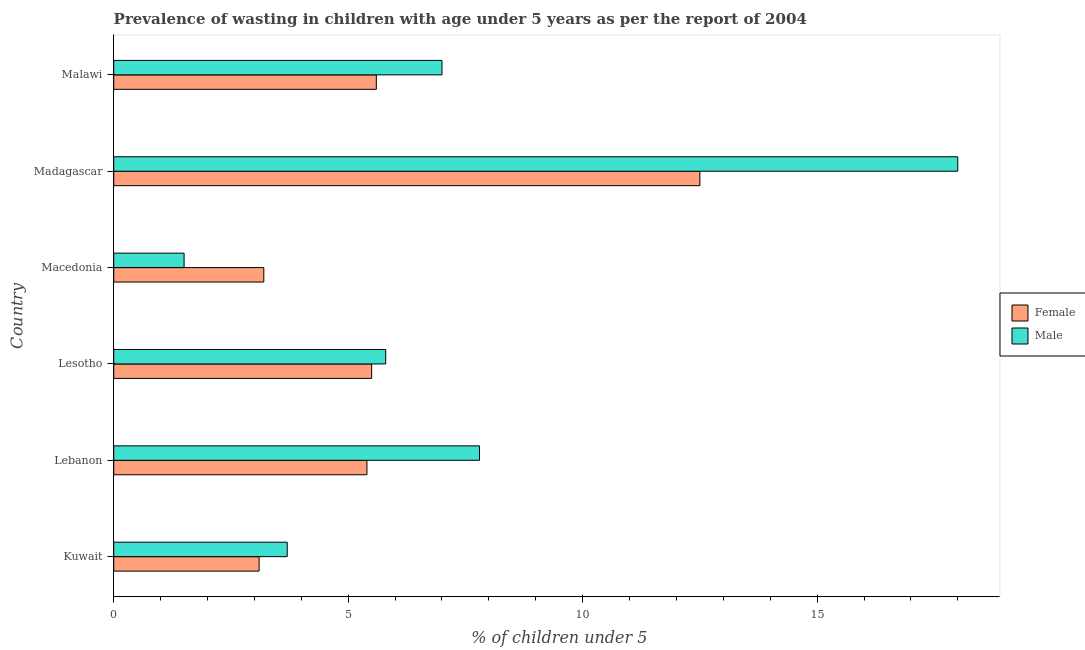How many different coloured bars are there?
Keep it short and to the point. 2. How many groups of bars are there?
Give a very brief answer. 6. Are the number of bars per tick equal to the number of legend labels?
Ensure brevity in your answer.  Yes. What is the label of the 3rd group of bars from the top?
Provide a succinct answer. Macedonia. In how many cases, is the number of bars for a given country not equal to the number of legend labels?
Give a very brief answer. 0. Across all countries, what is the maximum percentage of undernourished female children?
Offer a very short reply. 12.5. Across all countries, what is the minimum percentage of undernourished female children?
Provide a succinct answer. 3.1. In which country was the percentage of undernourished female children maximum?
Offer a terse response. Madagascar. In which country was the percentage of undernourished male children minimum?
Keep it short and to the point. Macedonia. What is the total percentage of undernourished female children in the graph?
Provide a short and direct response. 35.3. What is the difference between the percentage of undernourished male children in Lebanon and the percentage of undernourished female children in Macedonia?
Keep it short and to the point. 4.6. What is the average percentage of undernourished female children per country?
Your answer should be compact. 5.88. What is the difference between the percentage of undernourished male children and percentage of undernourished female children in Lebanon?
Offer a terse response. 2.4. What is the ratio of the percentage of undernourished male children in Kuwait to that in Lesotho?
Your answer should be very brief. 0.64. Is the difference between the percentage of undernourished male children in Lebanon and Madagascar greater than the difference between the percentage of undernourished female children in Lebanon and Madagascar?
Your answer should be compact. No. What is the difference between the highest and the second highest percentage of undernourished female children?
Your answer should be compact. 6.9. What is the difference between the highest and the lowest percentage of undernourished female children?
Offer a terse response. 9.4. In how many countries, is the percentage of undernourished female children greater than the average percentage of undernourished female children taken over all countries?
Provide a succinct answer. 1. Is the sum of the percentage of undernourished female children in Lebanon and Madagascar greater than the maximum percentage of undernourished male children across all countries?
Make the answer very short. No. What does the 1st bar from the bottom in Madagascar represents?
Offer a terse response. Female. How many bars are there?
Offer a very short reply. 12. Are all the bars in the graph horizontal?
Offer a very short reply. Yes. How many countries are there in the graph?
Offer a terse response. 6. What is the difference between two consecutive major ticks on the X-axis?
Your response must be concise. 5. Does the graph contain any zero values?
Provide a short and direct response. No. Where does the legend appear in the graph?
Ensure brevity in your answer.  Center right. How many legend labels are there?
Make the answer very short. 2. What is the title of the graph?
Give a very brief answer. Prevalence of wasting in children with age under 5 years as per the report of 2004. Does "Forest" appear as one of the legend labels in the graph?
Your answer should be compact. No. What is the label or title of the X-axis?
Your answer should be compact.  % of children under 5. What is the label or title of the Y-axis?
Ensure brevity in your answer.  Country. What is the  % of children under 5 of Female in Kuwait?
Provide a succinct answer. 3.1. What is the  % of children under 5 of Male in Kuwait?
Your response must be concise. 3.7. What is the  % of children under 5 in Female in Lebanon?
Your answer should be very brief. 5.4. What is the  % of children under 5 of Male in Lebanon?
Make the answer very short. 7.8. What is the  % of children under 5 of Male in Lesotho?
Keep it short and to the point. 5.8. What is the  % of children under 5 of Female in Macedonia?
Provide a succinct answer. 3.2. What is the  % of children under 5 of Male in Madagascar?
Offer a very short reply. 18. What is the  % of children under 5 in Female in Malawi?
Provide a succinct answer. 5.6. What is the  % of children under 5 in Male in Malawi?
Provide a succinct answer. 7. Across all countries, what is the maximum  % of children under 5 in Female?
Your answer should be compact. 12.5. Across all countries, what is the maximum  % of children under 5 in Male?
Make the answer very short. 18. Across all countries, what is the minimum  % of children under 5 in Female?
Offer a terse response. 3.1. Across all countries, what is the minimum  % of children under 5 in Male?
Keep it short and to the point. 1.5. What is the total  % of children under 5 in Female in the graph?
Ensure brevity in your answer.  35.3. What is the total  % of children under 5 of Male in the graph?
Offer a terse response. 43.8. What is the difference between the  % of children under 5 in Female in Kuwait and that in Lebanon?
Keep it short and to the point. -2.3. What is the difference between the  % of children under 5 in Female in Kuwait and that in Macedonia?
Provide a succinct answer. -0.1. What is the difference between the  % of children under 5 of Male in Kuwait and that in Macedonia?
Provide a short and direct response. 2.2. What is the difference between the  % of children under 5 of Male in Kuwait and that in Madagascar?
Provide a short and direct response. -14.3. What is the difference between the  % of children under 5 of Male in Kuwait and that in Malawi?
Keep it short and to the point. -3.3. What is the difference between the  % of children under 5 of Female in Lebanon and that in Lesotho?
Your answer should be very brief. -0.1. What is the difference between the  % of children under 5 of Female in Lebanon and that in Madagascar?
Keep it short and to the point. -7.1. What is the difference between the  % of children under 5 of Female in Lebanon and that in Malawi?
Your response must be concise. -0.2. What is the difference between the  % of children under 5 in Male in Lebanon and that in Malawi?
Your response must be concise. 0.8. What is the difference between the  % of children under 5 in Female in Lesotho and that in Madagascar?
Your response must be concise. -7. What is the difference between the  % of children under 5 in Male in Lesotho and that in Madagascar?
Ensure brevity in your answer.  -12.2. What is the difference between the  % of children under 5 of Female in Macedonia and that in Madagascar?
Your answer should be very brief. -9.3. What is the difference between the  % of children under 5 of Male in Macedonia and that in Madagascar?
Give a very brief answer. -16.5. What is the difference between the  % of children under 5 of Female in Macedonia and that in Malawi?
Provide a succinct answer. -2.4. What is the difference between the  % of children under 5 in Female in Kuwait and the  % of children under 5 in Male in Lesotho?
Your response must be concise. -2.7. What is the difference between the  % of children under 5 of Female in Kuwait and the  % of children under 5 of Male in Madagascar?
Offer a very short reply. -14.9. What is the difference between the  % of children under 5 in Female in Lebanon and the  % of children under 5 in Male in Lesotho?
Provide a succinct answer. -0.4. What is the difference between the  % of children under 5 of Female in Lebanon and the  % of children under 5 of Male in Macedonia?
Provide a succinct answer. 3.9. What is the difference between the  % of children under 5 in Female in Lebanon and the  % of children under 5 in Male in Malawi?
Your response must be concise. -1.6. What is the difference between the  % of children under 5 in Female in Macedonia and the  % of children under 5 in Male in Madagascar?
Give a very brief answer. -14.8. What is the average  % of children under 5 in Female per country?
Provide a short and direct response. 5.88. What is the difference between the  % of children under 5 of Female and  % of children under 5 of Male in Lesotho?
Your answer should be compact. -0.3. What is the difference between the  % of children under 5 in Female and  % of children under 5 in Male in Macedonia?
Keep it short and to the point. 1.7. What is the difference between the  % of children under 5 of Female and  % of children under 5 of Male in Madagascar?
Make the answer very short. -5.5. What is the ratio of the  % of children under 5 of Female in Kuwait to that in Lebanon?
Give a very brief answer. 0.57. What is the ratio of the  % of children under 5 in Male in Kuwait to that in Lebanon?
Make the answer very short. 0.47. What is the ratio of the  % of children under 5 in Female in Kuwait to that in Lesotho?
Ensure brevity in your answer.  0.56. What is the ratio of the  % of children under 5 in Male in Kuwait to that in Lesotho?
Keep it short and to the point. 0.64. What is the ratio of the  % of children under 5 in Female in Kuwait to that in Macedonia?
Give a very brief answer. 0.97. What is the ratio of the  % of children under 5 in Male in Kuwait to that in Macedonia?
Offer a very short reply. 2.47. What is the ratio of the  % of children under 5 in Female in Kuwait to that in Madagascar?
Ensure brevity in your answer.  0.25. What is the ratio of the  % of children under 5 in Male in Kuwait to that in Madagascar?
Keep it short and to the point. 0.21. What is the ratio of the  % of children under 5 of Female in Kuwait to that in Malawi?
Give a very brief answer. 0.55. What is the ratio of the  % of children under 5 in Male in Kuwait to that in Malawi?
Provide a succinct answer. 0.53. What is the ratio of the  % of children under 5 of Female in Lebanon to that in Lesotho?
Your response must be concise. 0.98. What is the ratio of the  % of children under 5 of Male in Lebanon to that in Lesotho?
Offer a terse response. 1.34. What is the ratio of the  % of children under 5 in Female in Lebanon to that in Macedonia?
Provide a short and direct response. 1.69. What is the ratio of the  % of children under 5 in Female in Lebanon to that in Madagascar?
Your response must be concise. 0.43. What is the ratio of the  % of children under 5 of Male in Lebanon to that in Madagascar?
Your answer should be compact. 0.43. What is the ratio of the  % of children under 5 in Male in Lebanon to that in Malawi?
Your response must be concise. 1.11. What is the ratio of the  % of children under 5 in Female in Lesotho to that in Macedonia?
Your answer should be compact. 1.72. What is the ratio of the  % of children under 5 of Male in Lesotho to that in Macedonia?
Provide a succinct answer. 3.87. What is the ratio of the  % of children under 5 of Female in Lesotho to that in Madagascar?
Offer a terse response. 0.44. What is the ratio of the  % of children under 5 of Male in Lesotho to that in Madagascar?
Your answer should be compact. 0.32. What is the ratio of the  % of children under 5 of Female in Lesotho to that in Malawi?
Provide a succinct answer. 0.98. What is the ratio of the  % of children under 5 of Male in Lesotho to that in Malawi?
Your answer should be compact. 0.83. What is the ratio of the  % of children under 5 of Female in Macedonia to that in Madagascar?
Your answer should be compact. 0.26. What is the ratio of the  % of children under 5 of Male in Macedonia to that in Madagascar?
Ensure brevity in your answer.  0.08. What is the ratio of the  % of children under 5 in Male in Macedonia to that in Malawi?
Provide a short and direct response. 0.21. What is the ratio of the  % of children under 5 in Female in Madagascar to that in Malawi?
Your response must be concise. 2.23. What is the ratio of the  % of children under 5 in Male in Madagascar to that in Malawi?
Give a very brief answer. 2.57. What is the difference between the highest and the second highest  % of children under 5 of Female?
Provide a succinct answer. 6.9. What is the difference between the highest and the lowest  % of children under 5 in Female?
Provide a short and direct response. 9.4. 